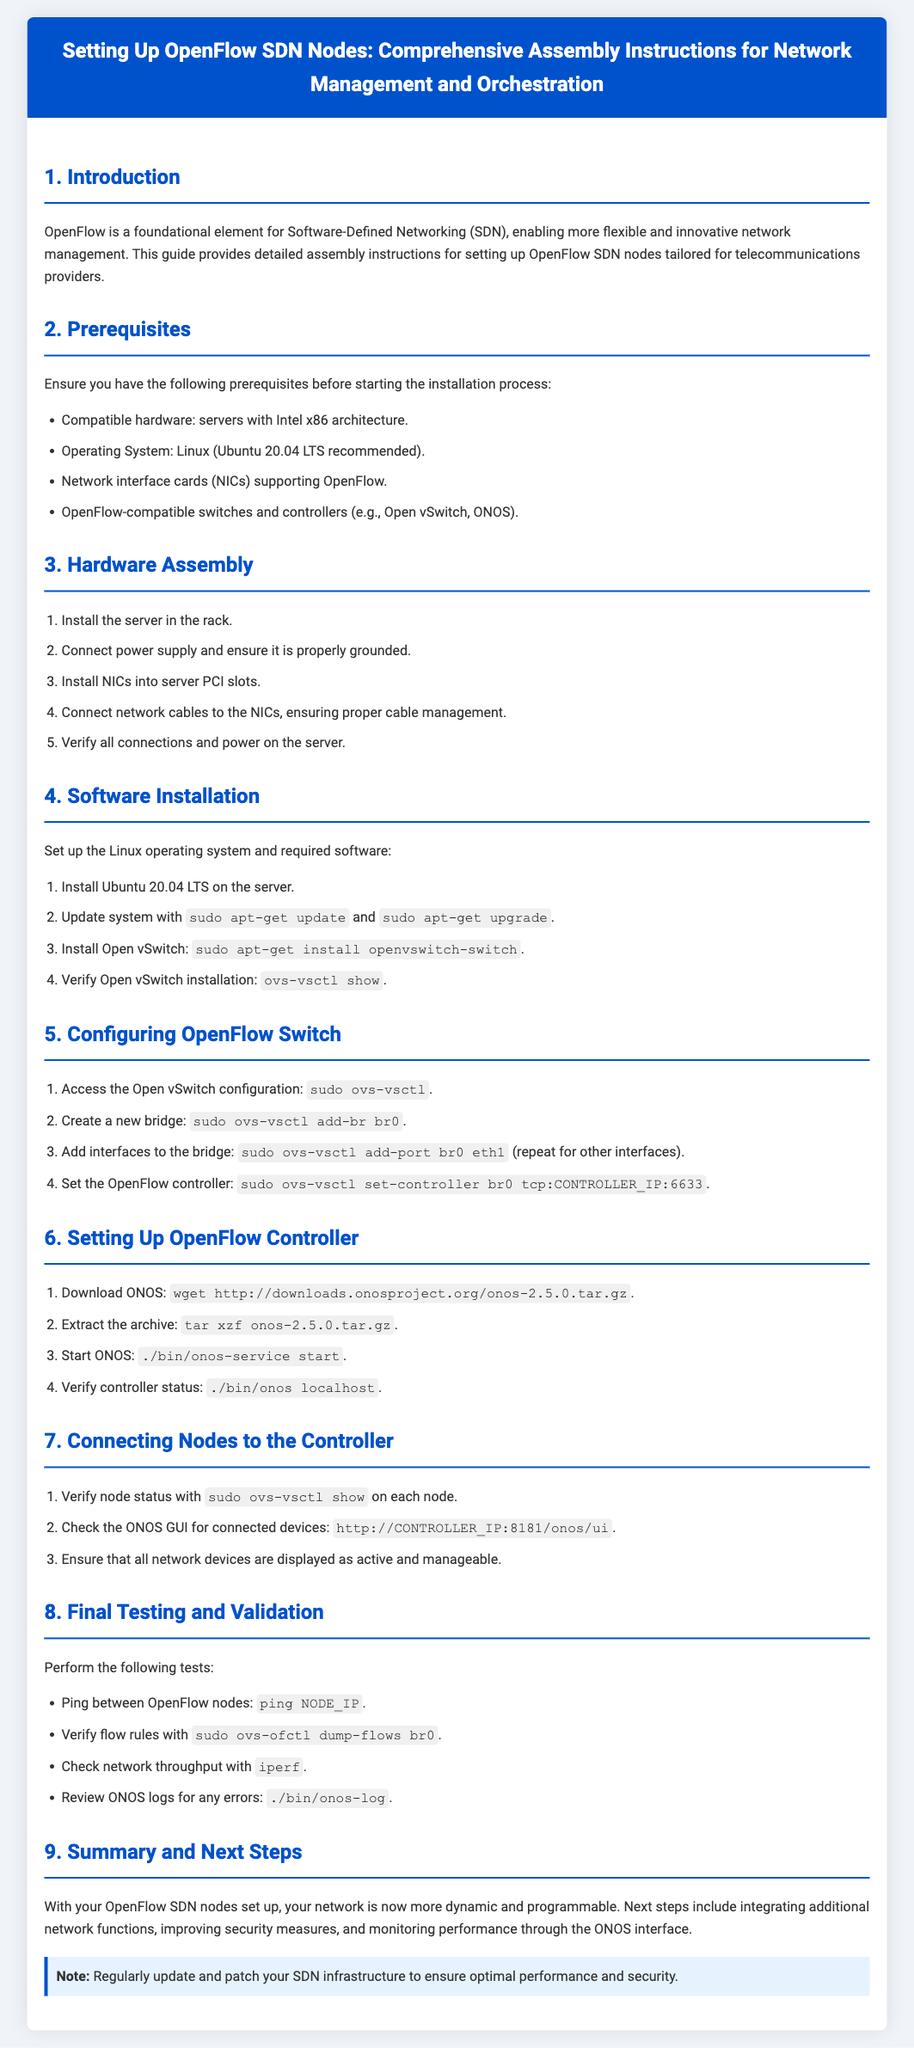What is required hardware for OpenFlow setup? The required hardware is listed as servers with Intel x86 architecture, NICs supporting OpenFlow, and OpenFlow-compatible switches.
Answer: Servers with Intel x86 architecture What operating system is recommended for installation? The document suggests Ubuntu 20.04 LTS as the recommended operating system for installation.
Answer: Ubuntu 20.04 LTS How many steps are in the Hardware Assembly section? The Hardware Assembly section outlines a total of five steps for setup.
Answer: Five What command is used to start ONOS? The command to start ONOS is specified clearly in the Software Installation section.
Answer: ./bin/onos-service start What should you do to verify flow rules? The document indicates a specific command to check the flow rules in the validation phase.
Answer: sudo ovs-ofctl dump-flows br0 What is the last section in the document about? The last section summarizes the setup and suggests next steps and maintenance for the SDN nodes.
Answer: Summary and Next Steps How can you access the ONOS GUI? The document specifies a web address format to access the ONOS GUI interface.
Answer: http://CONTROLLER_IP:8181/onos/ui What note is highlighted in the Summary and Next Steps section? The note emphasizes the importance of regular updates and patches for optimal performance and security.
Answer: Regularly update and patch your SDN infrastructure 